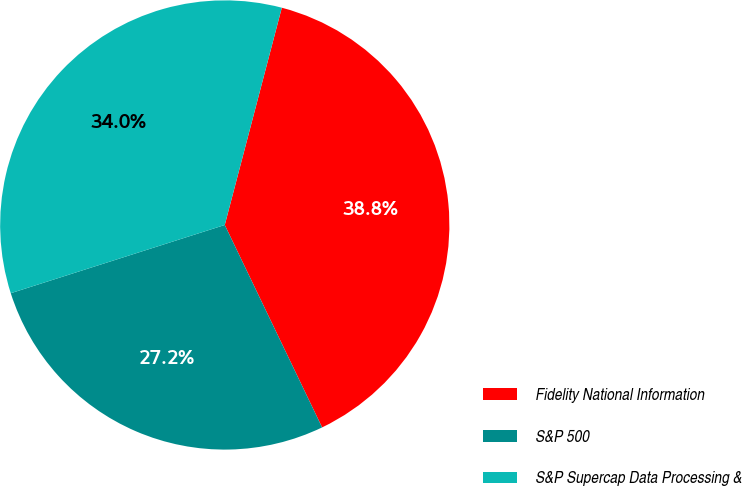Convert chart to OTSL. <chart><loc_0><loc_0><loc_500><loc_500><pie_chart><fcel>Fidelity National Information<fcel>S&P 500<fcel>S&P Supercap Data Processing &<nl><fcel>38.78%<fcel>27.22%<fcel>34.0%<nl></chart> 